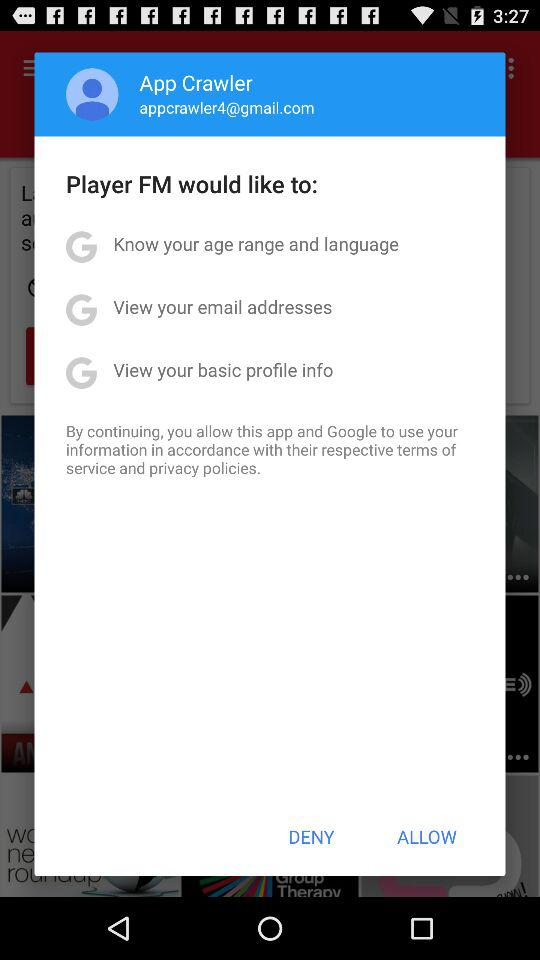What is the email address? The email address is appcrawler4@gmail.com. 